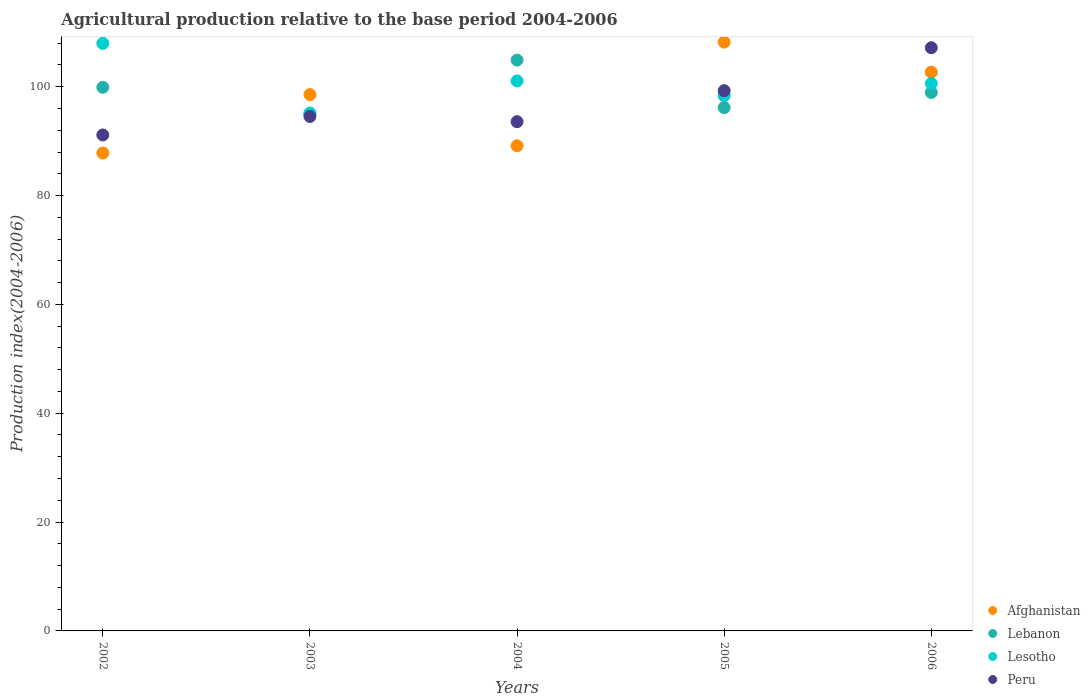How many different coloured dotlines are there?
Offer a very short reply. 4. What is the agricultural production index in Lesotho in 2005?
Provide a short and direct response. 98.35. Across all years, what is the maximum agricultural production index in Lebanon?
Offer a very short reply. 104.89. Across all years, what is the minimum agricultural production index in Lesotho?
Give a very brief answer. 95.16. In which year was the agricultural production index in Lebanon minimum?
Your answer should be compact. 2003. What is the total agricultural production index in Lesotho in the graph?
Ensure brevity in your answer.  503.12. What is the difference between the agricultural production index in Afghanistan in 2005 and that in 2006?
Offer a very short reply. 5.52. What is the difference between the agricultural production index in Afghanistan in 2002 and the agricultural production index in Lesotho in 2005?
Give a very brief answer. -10.54. What is the average agricultural production index in Peru per year?
Give a very brief answer. 97.13. In the year 2006, what is the difference between the agricultural production index in Lebanon and agricultural production index in Afghanistan?
Make the answer very short. -3.73. What is the ratio of the agricultural production index in Lesotho in 2003 to that in 2004?
Offer a terse response. 0.94. Is the agricultural production index in Lebanon in 2002 less than that in 2005?
Make the answer very short. No. Is the difference between the agricultural production index in Lebanon in 2002 and 2005 greater than the difference between the agricultural production index in Afghanistan in 2002 and 2005?
Provide a succinct answer. Yes. What is the difference between the highest and the second highest agricultural production index in Lesotho?
Make the answer very short. 6.9. What is the difference between the highest and the lowest agricultural production index in Peru?
Your answer should be very brief. 16.03. Is the sum of the agricultural production index in Lesotho in 2005 and 2006 greater than the maximum agricultural production index in Lebanon across all years?
Make the answer very short. Yes. Is it the case that in every year, the sum of the agricultural production index in Lebanon and agricultural production index in Lesotho  is greater than the agricultural production index in Peru?
Your answer should be compact. Yes. Is the agricultural production index in Lesotho strictly greater than the agricultural production index in Peru over the years?
Provide a succinct answer. No. Is the agricultural production index in Lebanon strictly less than the agricultural production index in Lesotho over the years?
Your response must be concise. No. How many dotlines are there?
Ensure brevity in your answer.  4. How many years are there in the graph?
Keep it short and to the point. 5. Does the graph contain any zero values?
Provide a short and direct response. No. Does the graph contain grids?
Offer a very short reply. No. Where does the legend appear in the graph?
Your answer should be very brief. Bottom right. How many legend labels are there?
Give a very brief answer. 4. How are the legend labels stacked?
Give a very brief answer. Vertical. What is the title of the graph?
Your answer should be very brief. Agricultural production relative to the base period 2004-2006. Does "Faeroe Islands" appear as one of the legend labels in the graph?
Offer a terse response. No. What is the label or title of the X-axis?
Your answer should be compact. Years. What is the label or title of the Y-axis?
Make the answer very short. Production index(2004-2006). What is the Production index(2004-2006) in Afghanistan in 2002?
Make the answer very short. 87.81. What is the Production index(2004-2006) in Lebanon in 2002?
Give a very brief answer. 99.89. What is the Production index(2004-2006) of Lesotho in 2002?
Offer a terse response. 107.96. What is the Production index(2004-2006) of Peru in 2002?
Ensure brevity in your answer.  91.13. What is the Production index(2004-2006) in Afghanistan in 2003?
Provide a succinct answer. 98.55. What is the Production index(2004-2006) of Lebanon in 2003?
Provide a succinct answer. 95.02. What is the Production index(2004-2006) in Lesotho in 2003?
Your answer should be compact. 95.16. What is the Production index(2004-2006) of Peru in 2003?
Your response must be concise. 94.53. What is the Production index(2004-2006) in Afghanistan in 2004?
Offer a very short reply. 89.14. What is the Production index(2004-2006) in Lebanon in 2004?
Ensure brevity in your answer.  104.89. What is the Production index(2004-2006) in Lesotho in 2004?
Your response must be concise. 101.06. What is the Production index(2004-2006) in Peru in 2004?
Your answer should be compact. 93.57. What is the Production index(2004-2006) in Afghanistan in 2005?
Your response must be concise. 108.19. What is the Production index(2004-2006) in Lebanon in 2005?
Make the answer very short. 96.16. What is the Production index(2004-2006) in Lesotho in 2005?
Offer a terse response. 98.35. What is the Production index(2004-2006) of Peru in 2005?
Provide a short and direct response. 99.27. What is the Production index(2004-2006) of Afghanistan in 2006?
Provide a short and direct response. 102.67. What is the Production index(2004-2006) in Lebanon in 2006?
Give a very brief answer. 98.94. What is the Production index(2004-2006) in Lesotho in 2006?
Give a very brief answer. 100.59. What is the Production index(2004-2006) in Peru in 2006?
Make the answer very short. 107.16. Across all years, what is the maximum Production index(2004-2006) in Afghanistan?
Keep it short and to the point. 108.19. Across all years, what is the maximum Production index(2004-2006) in Lebanon?
Give a very brief answer. 104.89. Across all years, what is the maximum Production index(2004-2006) in Lesotho?
Ensure brevity in your answer.  107.96. Across all years, what is the maximum Production index(2004-2006) of Peru?
Your answer should be very brief. 107.16. Across all years, what is the minimum Production index(2004-2006) of Afghanistan?
Your answer should be compact. 87.81. Across all years, what is the minimum Production index(2004-2006) in Lebanon?
Provide a short and direct response. 95.02. Across all years, what is the minimum Production index(2004-2006) of Lesotho?
Offer a terse response. 95.16. Across all years, what is the minimum Production index(2004-2006) in Peru?
Your answer should be compact. 91.13. What is the total Production index(2004-2006) in Afghanistan in the graph?
Make the answer very short. 486.36. What is the total Production index(2004-2006) in Lebanon in the graph?
Your answer should be very brief. 494.9. What is the total Production index(2004-2006) in Lesotho in the graph?
Keep it short and to the point. 503.12. What is the total Production index(2004-2006) of Peru in the graph?
Offer a terse response. 485.66. What is the difference between the Production index(2004-2006) of Afghanistan in 2002 and that in 2003?
Keep it short and to the point. -10.74. What is the difference between the Production index(2004-2006) of Lebanon in 2002 and that in 2003?
Keep it short and to the point. 4.87. What is the difference between the Production index(2004-2006) in Peru in 2002 and that in 2003?
Your response must be concise. -3.4. What is the difference between the Production index(2004-2006) in Afghanistan in 2002 and that in 2004?
Ensure brevity in your answer.  -1.33. What is the difference between the Production index(2004-2006) of Lesotho in 2002 and that in 2004?
Make the answer very short. 6.9. What is the difference between the Production index(2004-2006) of Peru in 2002 and that in 2004?
Make the answer very short. -2.44. What is the difference between the Production index(2004-2006) of Afghanistan in 2002 and that in 2005?
Make the answer very short. -20.38. What is the difference between the Production index(2004-2006) in Lebanon in 2002 and that in 2005?
Offer a very short reply. 3.73. What is the difference between the Production index(2004-2006) in Lesotho in 2002 and that in 2005?
Provide a succinct answer. 9.61. What is the difference between the Production index(2004-2006) of Peru in 2002 and that in 2005?
Your answer should be very brief. -8.14. What is the difference between the Production index(2004-2006) in Afghanistan in 2002 and that in 2006?
Ensure brevity in your answer.  -14.86. What is the difference between the Production index(2004-2006) in Lesotho in 2002 and that in 2006?
Your answer should be compact. 7.37. What is the difference between the Production index(2004-2006) of Peru in 2002 and that in 2006?
Your response must be concise. -16.03. What is the difference between the Production index(2004-2006) of Afghanistan in 2003 and that in 2004?
Make the answer very short. 9.41. What is the difference between the Production index(2004-2006) of Lebanon in 2003 and that in 2004?
Your answer should be compact. -9.87. What is the difference between the Production index(2004-2006) in Lesotho in 2003 and that in 2004?
Provide a short and direct response. -5.9. What is the difference between the Production index(2004-2006) of Afghanistan in 2003 and that in 2005?
Ensure brevity in your answer.  -9.64. What is the difference between the Production index(2004-2006) in Lebanon in 2003 and that in 2005?
Provide a short and direct response. -1.14. What is the difference between the Production index(2004-2006) of Lesotho in 2003 and that in 2005?
Your answer should be very brief. -3.19. What is the difference between the Production index(2004-2006) of Peru in 2003 and that in 2005?
Provide a succinct answer. -4.74. What is the difference between the Production index(2004-2006) in Afghanistan in 2003 and that in 2006?
Ensure brevity in your answer.  -4.12. What is the difference between the Production index(2004-2006) in Lebanon in 2003 and that in 2006?
Offer a very short reply. -3.92. What is the difference between the Production index(2004-2006) of Lesotho in 2003 and that in 2006?
Offer a very short reply. -5.43. What is the difference between the Production index(2004-2006) in Peru in 2003 and that in 2006?
Provide a short and direct response. -12.63. What is the difference between the Production index(2004-2006) in Afghanistan in 2004 and that in 2005?
Give a very brief answer. -19.05. What is the difference between the Production index(2004-2006) in Lebanon in 2004 and that in 2005?
Provide a short and direct response. 8.73. What is the difference between the Production index(2004-2006) of Lesotho in 2004 and that in 2005?
Your response must be concise. 2.71. What is the difference between the Production index(2004-2006) in Afghanistan in 2004 and that in 2006?
Offer a very short reply. -13.53. What is the difference between the Production index(2004-2006) in Lebanon in 2004 and that in 2006?
Give a very brief answer. 5.95. What is the difference between the Production index(2004-2006) in Lesotho in 2004 and that in 2006?
Give a very brief answer. 0.47. What is the difference between the Production index(2004-2006) of Peru in 2004 and that in 2006?
Offer a very short reply. -13.59. What is the difference between the Production index(2004-2006) of Afghanistan in 2005 and that in 2006?
Make the answer very short. 5.52. What is the difference between the Production index(2004-2006) in Lebanon in 2005 and that in 2006?
Your answer should be very brief. -2.78. What is the difference between the Production index(2004-2006) of Lesotho in 2005 and that in 2006?
Provide a short and direct response. -2.24. What is the difference between the Production index(2004-2006) of Peru in 2005 and that in 2006?
Your answer should be very brief. -7.89. What is the difference between the Production index(2004-2006) of Afghanistan in 2002 and the Production index(2004-2006) of Lebanon in 2003?
Ensure brevity in your answer.  -7.21. What is the difference between the Production index(2004-2006) of Afghanistan in 2002 and the Production index(2004-2006) of Lesotho in 2003?
Provide a short and direct response. -7.35. What is the difference between the Production index(2004-2006) of Afghanistan in 2002 and the Production index(2004-2006) of Peru in 2003?
Ensure brevity in your answer.  -6.72. What is the difference between the Production index(2004-2006) in Lebanon in 2002 and the Production index(2004-2006) in Lesotho in 2003?
Provide a succinct answer. 4.73. What is the difference between the Production index(2004-2006) in Lebanon in 2002 and the Production index(2004-2006) in Peru in 2003?
Your answer should be compact. 5.36. What is the difference between the Production index(2004-2006) in Lesotho in 2002 and the Production index(2004-2006) in Peru in 2003?
Make the answer very short. 13.43. What is the difference between the Production index(2004-2006) of Afghanistan in 2002 and the Production index(2004-2006) of Lebanon in 2004?
Offer a terse response. -17.08. What is the difference between the Production index(2004-2006) of Afghanistan in 2002 and the Production index(2004-2006) of Lesotho in 2004?
Ensure brevity in your answer.  -13.25. What is the difference between the Production index(2004-2006) in Afghanistan in 2002 and the Production index(2004-2006) in Peru in 2004?
Ensure brevity in your answer.  -5.76. What is the difference between the Production index(2004-2006) of Lebanon in 2002 and the Production index(2004-2006) of Lesotho in 2004?
Give a very brief answer. -1.17. What is the difference between the Production index(2004-2006) in Lebanon in 2002 and the Production index(2004-2006) in Peru in 2004?
Give a very brief answer. 6.32. What is the difference between the Production index(2004-2006) in Lesotho in 2002 and the Production index(2004-2006) in Peru in 2004?
Offer a very short reply. 14.39. What is the difference between the Production index(2004-2006) in Afghanistan in 2002 and the Production index(2004-2006) in Lebanon in 2005?
Offer a terse response. -8.35. What is the difference between the Production index(2004-2006) of Afghanistan in 2002 and the Production index(2004-2006) of Lesotho in 2005?
Give a very brief answer. -10.54. What is the difference between the Production index(2004-2006) in Afghanistan in 2002 and the Production index(2004-2006) in Peru in 2005?
Your response must be concise. -11.46. What is the difference between the Production index(2004-2006) in Lebanon in 2002 and the Production index(2004-2006) in Lesotho in 2005?
Give a very brief answer. 1.54. What is the difference between the Production index(2004-2006) of Lebanon in 2002 and the Production index(2004-2006) of Peru in 2005?
Provide a succinct answer. 0.62. What is the difference between the Production index(2004-2006) in Lesotho in 2002 and the Production index(2004-2006) in Peru in 2005?
Your answer should be very brief. 8.69. What is the difference between the Production index(2004-2006) in Afghanistan in 2002 and the Production index(2004-2006) in Lebanon in 2006?
Your answer should be compact. -11.13. What is the difference between the Production index(2004-2006) of Afghanistan in 2002 and the Production index(2004-2006) of Lesotho in 2006?
Make the answer very short. -12.78. What is the difference between the Production index(2004-2006) of Afghanistan in 2002 and the Production index(2004-2006) of Peru in 2006?
Provide a succinct answer. -19.35. What is the difference between the Production index(2004-2006) of Lebanon in 2002 and the Production index(2004-2006) of Lesotho in 2006?
Your answer should be very brief. -0.7. What is the difference between the Production index(2004-2006) in Lebanon in 2002 and the Production index(2004-2006) in Peru in 2006?
Your answer should be very brief. -7.27. What is the difference between the Production index(2004-2006) of Lesotho in 2002 and the Production index(2004-2006) of Peru in 2006?
Give a very brief answer. 0.8. What is the difference between the Production index(2004-2006) of Afghanistan in 2003 and the Production index(2004-2006) of Lebanon in 2004?
Your response must be concise. -6.34. What is the difference between the Production index(2004-2006) of Afghanistan in 2003 and the Production index(2004-2006) of Lesotho in 2004?
Your response must be concise. -2.51. What is the difference between the Production index(2004-2006) of Afghanistan in 2003 and the Production index(2004-2006) of Peru in 2004?
Provide a succinct answer. 4.98. What is the difference between the Production index(2004-2006) in Lebanon in 2003 and the Production index(2004-2006) in Lesotho in 2004?
Your answer should be compact. -6.04. What is the difference between the Production index(2004-2006) in Lebanon in 2003 and the Production index(2004-2006) in Peru in 2004?
Keep it short and to the point. 1.45. What is the difference between the Production index(2004-2006) in Lesotho in 2003 and the Production index(2004-2006) in Peru in 2004?
Provide a short and direct response. 1.59. What is the difference between the Production index(2004-2006) of Afghanistan in 2003 and the Production index(2004-2006) of Lebanon in 2005?
Give a very brief answer. 2.39. What is the difference between the Production index(2004-2006) of Afghanistan in 2003 and the Production index(2004-2006) of Peru in 2005?
Make the answer very short. -0.72. What is the difference between the Production index(2004-2006) of Lebanon in 2003 and the Production index(2004-2006) of Lesotho in 2005?
Your response must be concise. -3.33. What is the difference between the Production index(2004-2006) of Lebanon in 2003 and the Production index(2004-2006) of Peru in 2005?
Ensure brevity in your answer.  -4.25. What is the difference between the Production index(2004-2006) of Lesotho in 2003 and the Production index(2004-2006) of Peru in 2005?
Give a very brief answer. -4.11. What is the difference between the Production index(2004-2006) of Afghanistan in 2003 and the Production index(2004-2006) of Lebanon in 2006?
Offer a terse response. -0.39. What is the difference between the Production index(2004-2006) in Afghanistan in 2003 and the Production index(2004-2006) in Lesotho in 2006?
Provide a succinct answer. -2.04. What is the difference between the Production index(2004-2006) of Afghanistan in 2003 and the Production index(2004-2006) of Peru in 2006?
Your response must be concise. -8.61. What is the difference between the Production index(2004-2006) in Lebanon in 2003 and the Production index(2004-2006) in Lesotho in 2006?
Your answer should be compact. -5.57. What is the difference between the Production index(2004-2006) of Lebanon in 2003 and the Production index(2004-2006) of Peru in 2006?
Provide a short and direct response. -12.14. What is the difference between the Production index(2004-2006) of Lesotho in 2003 and the Production index(2004-2006) of Peru in 2006?
Ensure brevity in your answer.  -12. What is the difference between the Production index(2004-2006) of Afghanistan in 2004 and the Production index(2004-2006) of Lebanon in 2005?
Give a very brief answer. -7.02. What is the difference between the Production index(2004-2006) of Afghanistan in 2004 and the Production index(2004-2006) of Lesotho in 2005?
Your answer should be compact. -9.21. What is the difference between the Production index(2004-2006) of Afghanistan in 2004 and the Production index(2004-2006) of Peru in 2005?
Offer a very short reply. -10.13. What is the difference between the Production index(2004-2006) in Lebanon in 2004 and the Production index(2004-2006) in Lesotho in 2005?
Your answer should be very brief. 6.54. What is the difference between the Production index(2004-2006) of Lebanon in 2004 and the Production index(2004-2006) of Peru in 2005?
Your answer should be compact. 5.62. What is the difference between the Production index(2004-2006) of Lesotho in 2004 and the Production index(2004-2006) of Peru in 2005?
Keep it short and to the point. 1.79. What is the difference between the Production index(2004-2006) in Afghanistan in 2004 and the Production index(2004-2006) in Lesotho in 2006?
Give a very brief answer. -11.45. What is the difference between the Production index(2004-2006) in Afghanistan in 2004 and the Production index(2004-2006) in Peru in 2006?
Keep it short and to the point. -18.02. What is the difference between the Production index(2004-2006) of Lebanon in 2004 and the Production index(2004-2006) of Peru in 2006?
Your answer should be very brief. -2.27. What is the difference between the Production index(2004-2006) of Lesotho in 2004 and the Production index(2004-2006) of Peru in 2006?
Ensure brevity in your answer.  -6.1. What is the difference between the Production index(2004-2006) of Afghanistan in 2005 and the Production index(2004-2006) of Lebanon in 2006?
Provide a short and direct response. 9.25. What is the difference between the Production index(2004-2006) of Afghanistan in 2005 and the Production index(2004-2006) of Lesotho in 2006?
Your response must be concise. 7.6. What is the difference between the Production index(2004-2006) of Afghanistan in 2005 and the Production index(2004-2006) of Peru in 2006?
Give a very brief answer. 1.03. What is the difference between the Production index(2004-2006) in Lebanon in 2005 and the Production index(2004-2006) in Lesotho in 2006?
Give a very brief answer. -4.43. What is the difference between the Production index(2004-2006) of Lebanon in 2005 and the Production index(2004-2006) of Peru in 2006?
Provide a short and direct response. -11. What is the difference between the Production index(2004-2006) in Lesotho in 2005 and the Production index(2004-2006) in Peru in 2006?
Provide a short and direct response. -8.81. What is the average Production index(2004-2006) in Afghanistan per year?
Keep it short and to the point. 97.27. What is the average Production index(2004-2006) in Lebanon per year?
Provide a succinct answer. 98.98. What is the average Production index(2004-2006) in Lesotho per year?
Provide a succinct answer. 100.62. What is the average Production index(2004-2006) of Peru per year?
Your answer should be compact. 97.13. In the year 2002, what is the difference between the Production index(2004-2006) of Afghanistan and Production index(2004-2006) of Lebanon?
Your response must be concise. -12.08. In the year 2002, what is the difference between the Production index(2004-2006) of Afghanistan and Production index(2004-2006) of Lesotho?
Your answer should be very brief. -20.15. In the year 2002, what is the difference between the Production index(2004-2006) of Afghanistan and Production index(2004-2006) of Peru?
Make the answer very short. -3.32. In the year 2002, what is the difference between the Production index(2004-2006) in Lebanon and Production index(2004-2006) in Lesotho?
Ensure brevity in your answer.  -8.07. In the year 2002, what is the difference between the Production index(2004-2006) in Lebanon and Production index(2004-2006) in Peru?
Keep it short and to the point. 8.76. In the year 2002, what is the difference between the Production index(2004-2006) of Lesotho and Production index(2004-2006) of Peru?
Your response must be concise. 16.83. In the year 2003, what is the difference between the Production index(2004-2006) of Afghanistan and Production index(2004-2006) of Lebanon?
Your answer should be compact. 3.53. In the year 2003, what is the difference between the Production index(2004-2006) of Afghanistan and Production index(2004-2006) of Lesotho?
Provide a short and direct response. 3.39. In the year 2003, what is the difference between the Production index(2004-2006) in Afghanistan and Production index(2004-2006) in Peru?
Your response must be concise. 4.02. In the year 2003, what is the difference between the Production index(2004-2006) in Lebanon and Production index(2004-2006) in Lesotho?
Ensure brevity in your answer.  -0.14. In the year 2003, what is the difference between the Production index(2004-2006) of Lebanon and Production index(2004-2006) of Peru?
Your response must be concise. 0.49. In the year 2003, what is the difference between the Production index(2004-2006) of Lesotho and Production index(2004-2006) of Peru?
Provide a succinct answer. 0.63. In the year 2004, what is the difference between the Production index(2004-2006) in Afghanistan and Production index(2004-2006) in Lebanon?
Provide a succinct answer. -15.75. In the year 2004, what is the difference between the Production index(2004-2006) of Afghanistan and Production index(2004-2006) of Lesotho?
Keep it short and to the point. -11.92. In the year 2004, what is the difference between the Production index(2004-2006) of Afghanistan and Production index(2004-2006) of Peru?
Your response must be concise. -4.43. In the year 2004, what is the difference between the Production index(2004-2006) in Lebanon and Production index(2004-2006) in Lesotho?
Your answer should be compact. 3.83. In the year 2004, what is the difference between the Production index(2004-2006) in Lebanon and Production index(2004-2006) in Peru?
Ensure brevity in your answer.  11.32. In the year 2004, what is the difference between the Production index(2004-2006) in Lesotho and Production index(2004-2006) in Peru?
Your answer should be very brief. 7.49. In the year 2005, what is the difference between the Production index(2004-2006) in Afghanistan and Production index(2004-2006) in Lebanon?
Your answer should be very brief. 12.03. In the year 2005, what is the difference between the Production index(2004-2006) of Afghanistan and Production index(2004-2006) of Lesotho?
Provide a succinct answer. 9.84. In the year 2005, what is the difference between the Production index(2004-2006) of Afghanistan and Production index(2004-2006) of Peru?
Ensure brevity in your answer.  8.92. In the year 2005, what is the difference between the Production index(2004-2006) of Lebanon and Production index(2004-2006) of Lesotho?
Provide a succinct answer. -2.19. In the year 2005, what is the difference between the Production index(2004-2006) of Lebanon and Production index(2004-2006) of Peru?
Make the answer very short. -3.11. In the year 2005, what is the difference between the Production index(2004-2006) in Lesotho and Production index(2004-2006) in Peru?
Your response must be concise. -0.92. In the year 2006, what is the difference between the Production index(2004-2006) in Afghanistan and Production index(2004-2006) in Lebanon?
Keep it short and to the point. 3.73. In the year 2006, what is the difference between the Production index(2004-2006) of Afghanistan and Production index(2004-2006) of Lesotho?
Offer a very short reply. 2.08. In the year 2006, what is the difference between the Production index(2004-2006) in Afghanistan and Production index(2004-2006) in Peru?
Provide a short and direct response. -4.49. In the year 2006, what is the difference between the Production index(2004-2006) of Lebanon and Production index(2004-2006) of Lesotho?
Give a very brief answer. -1.65. In the year 2006, what is the difference between the Production index(2004-2006) in Lebanon and Production index(2004-2006) in Peru?
Make the answer very short. -8.22. In the year 2006, what is the difference between the Production index(2004-2006) of Lesotho and Production index(2004-2006) of Peru?
Your answer should be compact. -6.57. What is the ratio of the Production index(2004-2006) of Afghanistan in 2002 to that in 2003?
Ensure brevity in your answer.  0.89. What is the ratio of the Production index(2004-2006) in Lebanon in 2002 to that in 2003?
Your response must be concise. 1.05. What is the ratio of the Production index(2004-2006) of Lesotho in 2002 to that in 2003?
Provide a succinct answer. 1.13. What is the ratio of the Production index(2004-2006) in Afghanistan in 2002 to that in 2004?
Keep it short and to the point. 0.99. What is the ratio of the Production index(2004-2006) in Lebanon in 2002 to that in 2004?
Your answer should be very brief. 0.95. What is the ratio of the Production index(2004-2006) of Lesotho in 2002 to that in 2004?
Provide a short and direct response. 1.07. What is the ratio of the Production index(2004-2006) of Peru in 2002 to that in 2004?
Your answer should be compact. 0.97. What is the ratio of the Production index(2004-2006) in Afghanistan in 2002 to that in 2005?
Provide a short and direct response. 0.81. What is the ratio of the Production index(2004-2006) of Lebanon in 2002 to that in 2005?
Your answer should be compact. 1.04. What is the ratio of the Production index(2004-2006) in Lesotho in 2002 to that in 2005?
Offer a very short reply. 1.1. What is the ratio of the Production index(2004-2006) in Peru in 2002 to that in 2005?
Provide a succinct answer. 0.92. What is the ratio of the Production index(2004-2006) of Afghanistan in 2002 to that in 2006?
Offer a terse response. 0.86. What is the ratio of the Production index(2004-2006) in Lebanon in 2002 to that in 2006?
Provide a short and direct response. 1.01. What is the ratio of the Production index(2004-2006) of Lesotho in 2002 to that in 2006?
Make the answer very short. 1.07. What is the ratio of the Production index(2004-2006) in Peru in 2002 to that in 2006?
Keep it short and to the point. 0.85. What is the ratio of the Production index(2004-2006) of Afghanistan in 2003 to that in 2004?
Make the answer very short. 1.11. What is the ratio of the Production index(2004-2006) of Lebanon in 2003 to that in 2004?
Your answer should be very brief. 0.91. What is the ratio of the Production index(2004-2006) in Lesotho in 2003 to that in 2004?
Give a very brief answer. 0.94. What is the ratio of the Production index(2004-2006) of Peru in 2003 to that in 2004?
Provide a succinct answer. 1.01. What is the ratio of the Production index(2004-2006) of Afghanistan in 2003 to that in 2005?
Offer a very short reply. 0.91. What is the ratio of the Production index(2004-2006) of Lebanon in 2003 to that in 2005?
Offer a terse response. 0.99. What is the ratio of the Production index(2004-2006) of Lesotho in 2003 to that in 2005?
Your answer should be compact. 0.97. What is the ratio of the Production index(2004-2006) of Peru in 2003 to that in 2005?
Your response must be concise. 0.95. What is the ratio of the Production index(2004-2006) in Afghanistan in 2003 to that in 2006?
Make the answer very short. 0.96. What is the ratio of the Production index(2004-2006) in Lebanon in 2003 to that in 2006?
Your answer should be very brief. 0.96. What is the ratio of the Production index(2004-2006) of Lesotho in 2003 to that in 2006?
Offer a terse response. 0.95. What is the ratio of the Production index(2004-2006) in Peru in 2003 to that in 2006?
Give a very brief answer. 0.88. What is the ratio of the Production index(2004-2006) in Afghanistan in 2004 to that in 2005?
Your answer should be compact. 0.82. What is the ratio of the Production index(2004-2006) of Lebanon in 2004 to that in 2005?
Keep it short and to the point. 1.09. What is the ratio of the Production index(2004-2006) in Lesotho in 2004 to that in 2005?
Your response must be concise. 1.03. What is the ratio of the Production index(2004-2006) of Peru in 2004 to that in 2005?
Keep it short and to the point. 0.94. What is the ratio of the Production index(2004-2006) of Afghanistan in 2004 to that in 2006?
Keep it short and to the point. 0.87. What is the ratio of the Production index(2004-2006) of Lebanon in 2004 to that in 2006?
Offer a terse response. 1.06. What is the ratio of the Production index(2004-2006) in Lesotho in 2004 to that in 2006?
Your answer should be very brief. 1. What is the ratio of the Production index(2004-2006) of Peru in 2004 to that in 2006?
Ensure brevity in your answer.  0.87. What is the ratio of the Production index(2004-2006) of Afghanistan in 2005 to that in 2006?
Offer a very short reply. 1.05. What is the ratio of the Production index(2004-2006) in Lebanon in 2005 to that in 2006?
Provide a succinct answer. 0.97. What is the ratio of the Production index(2004-2006) of Lesotho in 2005 to that in 2006?
Provide a succinct answer. 0.98. What is the ratio of the Production index(2004-2006) in Peru in 2005 to that in 2006?
Make the answer very short. 0.93. What is the difference between the highest and the second highest Production index(2004-2006) of Afghanistan?
Keep it short and to the point. 5.52. What is the difference between the highest and the second highest Production index(2004-2006) in Peru?
Offer a very short reply. 7.89. What is the difference between the highest and the lowest Production index(2004-2006) of Afghanistan?
Make the answer very short. 20.38. What is the difference between the highest and the lowest Production index(2004-2006) in Lebanon?
Provide a succinct answer. 9.87. What is the difference between the highest and the lowest Production index(2004-2006) in Peru?
Provide a short and direct response. 16.03. 